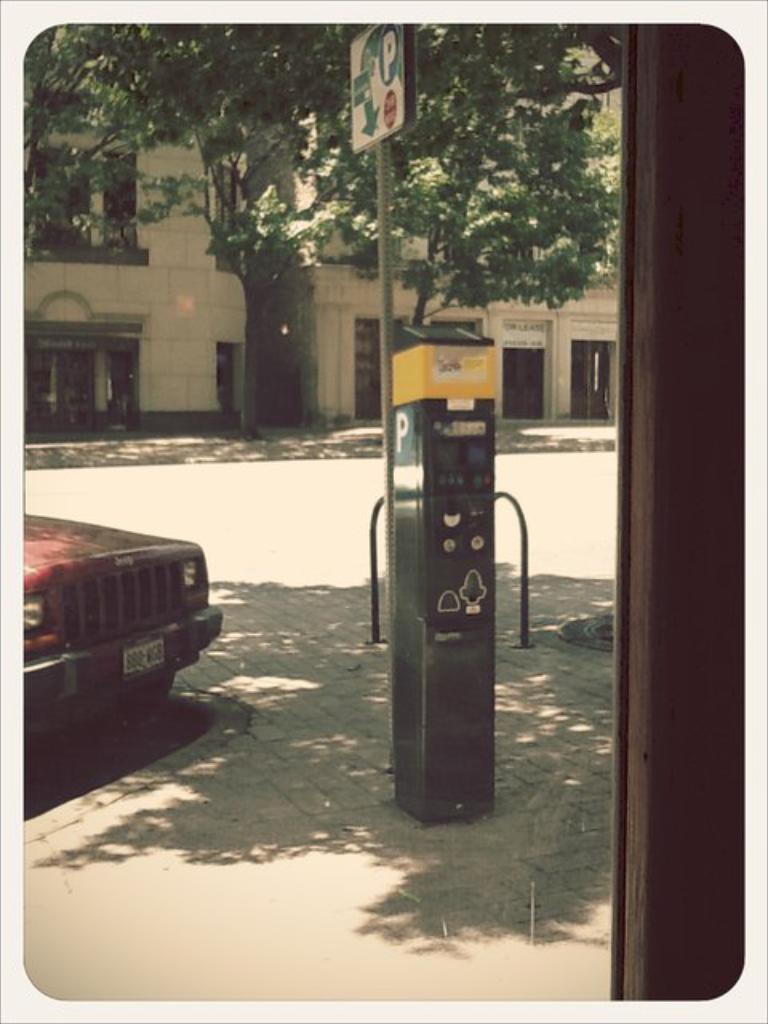Can you describe this image briefly? In this image I can see the ground, a parking meter which is green and yellow in color, a metal pole and a board to the pole, a car on the road, a tree which is green in color and few buildings. 